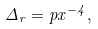<formula> <loc_0><loc_0><loc_500><loc_500>\Delta _ { r } = p x ^ { - 4 } ,</formula> 